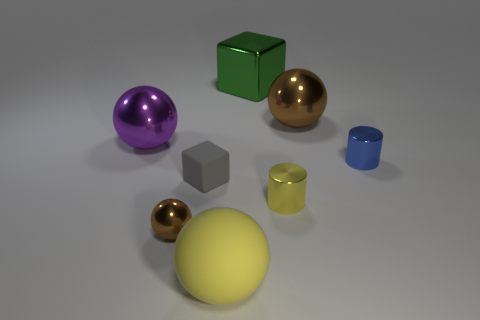There is a blue object that is to the right of the purple sphere; is its shape the same as the small yellow shiny thing?
Give a very brief answer. Yes. What number of rubber things are either gray cubes or large green objects?
Offer a very short reply. 1. Is there a big brown object made of the same material as the tiny gray block?
Offer a very short reply. No. What material is the tiny yellow cylinder?
Your answer should be compact. Metal. What is the shape of the metallic thing left of the brown sphere that is in front of the block in front of the large green object?
Make the answer very short. Sphere. Are there more tiny yellow cylinders on the right side of the big purple metallic ball than tiny yellow shiny spheres?
Your answer should be very brief. Yes. Do the small blue metal object and the yellow thing on the right side of the large yellow object have the same shape?
Keep it short and to the point. Yes. There is a tiny thing that is the same color as the large rubber ball; what shape is it?
Offer a terse response. Cylinder. How many tiny yellow metal objects are in front of the big thing that is in front of the large metal sphere left of the small sphere?
Make the answer very short. 0. What is the color of the metallic ball that is the same size as the gray rubber block?
Your answer should be compact. Brown. 